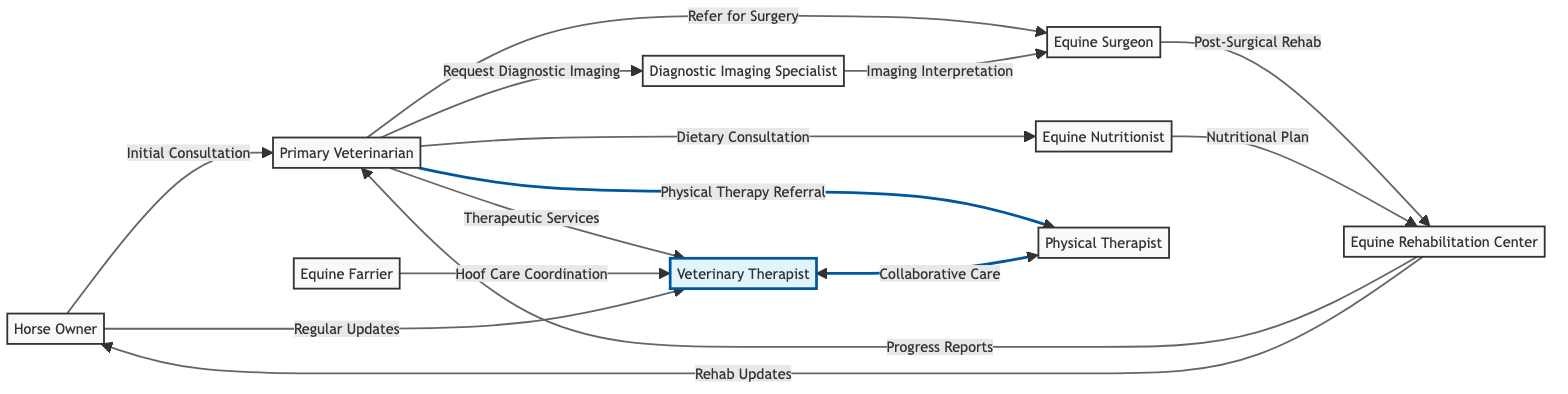What is the total number of nodes in the diagram? The nodes listed in the diagram are: Veterinary Therapist, Physical Therapist, Primary Veterinarian, Equine Surgeon, Diagnostic Imaging Specialist, Equine Nutritionist, Equine Farrier, Horse Owner, and Equine Rehabilitation Center. Counting these gives a total of 9 nodes.
Answer: 9 Who does the Horse Owner initially consult? The diagram shows that the Horse Owner connects to the Primary Veterinarian with the label "Initial Consultation," indicating that the first point of contact is the Primary Veterinarian.
Answer: Primary Veterinarian Which specialist receives imaging interpretation from the Diagnostic Imaging Specialist? The diagram indicates that the Diagnostic Imaging Specialist connects to the Equine Surgeon with the label "Imaging Interpretation," meaning the Equine Surgeon is the recipient of this service.
Answer: Equine Surgeon What kind of services does the Primary Veterinarian refer to the Veterinary Therapist? The diagram specifies that the Primary Veterinarian refers to the Veterinary Therapist for "Therapeutic Services," thereby defining the type of services involved in this relationship.
Answer: Therapeutic Services Which two professionals collaborate in care according to the diagram? The connection is shown between the Veterinary Therapist and the Physical Therapist, labeled "Collaborative Care," indicating that these two roles work together for the horse's well-being.
Answer: Veterinary Therapist and Physical Therapist What type of updates does the Horse Owner receive from the Veterinary Therapist? The diagram states that the Horse Owner connects to the Veterinary Therapist with the label "Regular Updates," which specifies the nature of the communication between these two entities.
Answer: Regular Updates How many connections does the Equine Rehabilitation Center have? The Equine Rehabilitation Center connects to three entities: Primary Veterinarian (Progress Reports), Horse Owner (Rehab Updates), and Equine Surgeon (Post-Surgical Rehab). Thus, it has a total of 3 connections.
Answer: 3 Which entity is responsible for providing a Nutritional Plan to the Equine Rehabilitation Center? According to the diagram, the Equine Nutritionist has a connection to the Equine Rehabilitation Center labeled "Nutritional Plan," designating this role as responsible for nutrition-related planning.
Answer: Equine Nutritionist Which node receives reports from the Equine Rehabilitation Center? The diagram shows that the Equine Rehabilitation Center connects back to the Primary Veterinarian and the Horse Owner, both labeled as providing different types of reports (Progress Reports and Rehab Updates, respectively). This indicates that both receive relevant updates.
Answer: Primary Veterinarian and Horse Owner 